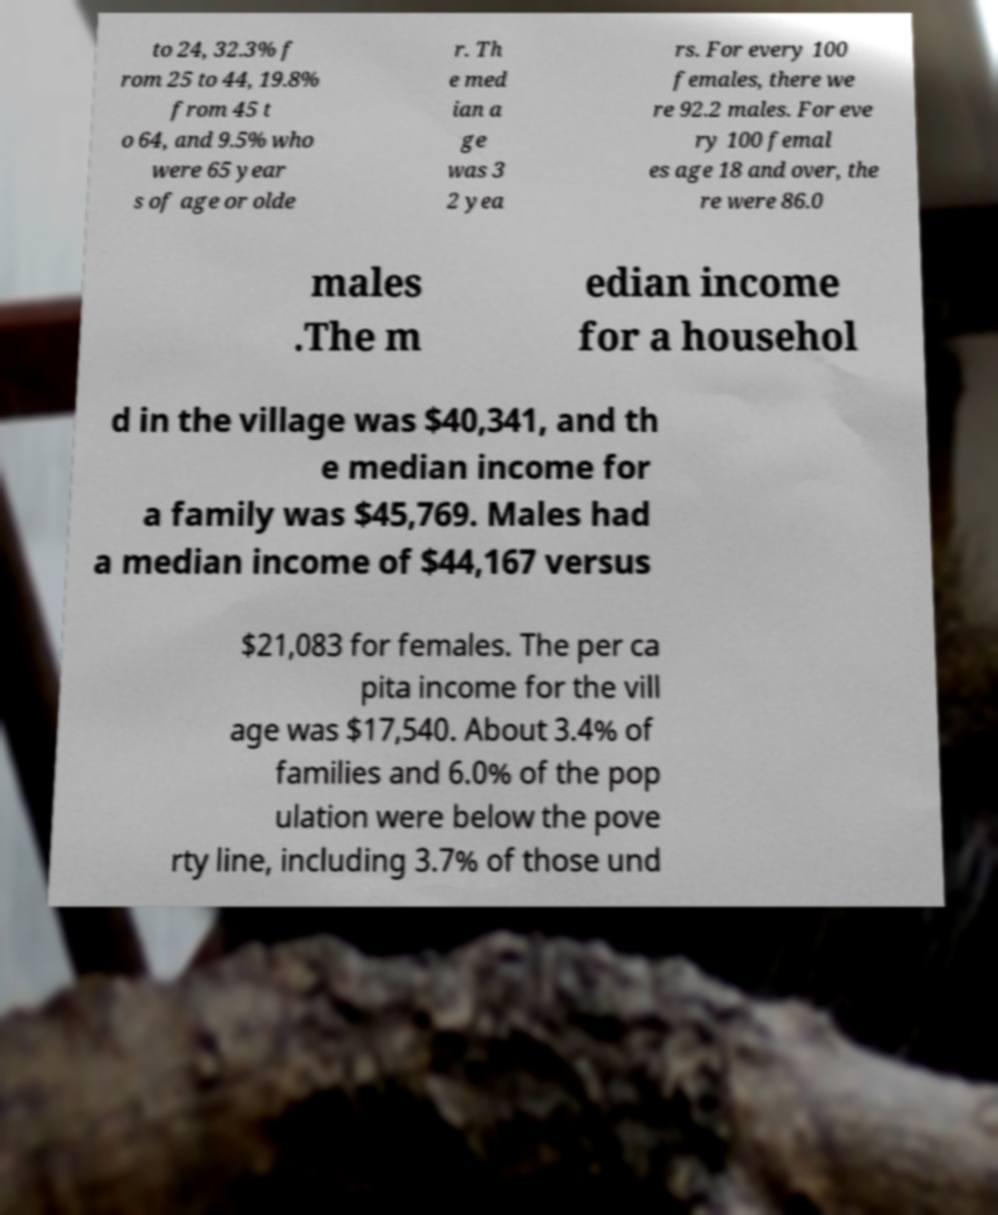Can you accurately transcribe the text from the provided image for me? to 24, 32.3% f rom 25 to 44, 19.8% from 45 t o 64, and 9.5% who were 65 year s of age or olde r. Th e med ian a ge was 3 2 yea rs. For every 100 females, there we re 92.2 males. For eve ry 100 femal es age 18 and over, the re were 86.0 males .The m edian income for a househol d in the village was $40,341, and th e median income for a family was $45,769. Males had a median income of $44,167 versus $21,083 for females. The per ca pita income for the vill age was $17,540. About 3.4% of families and 6.0% of the pop ulation were below the pove rty line, including 3.7% of those und 